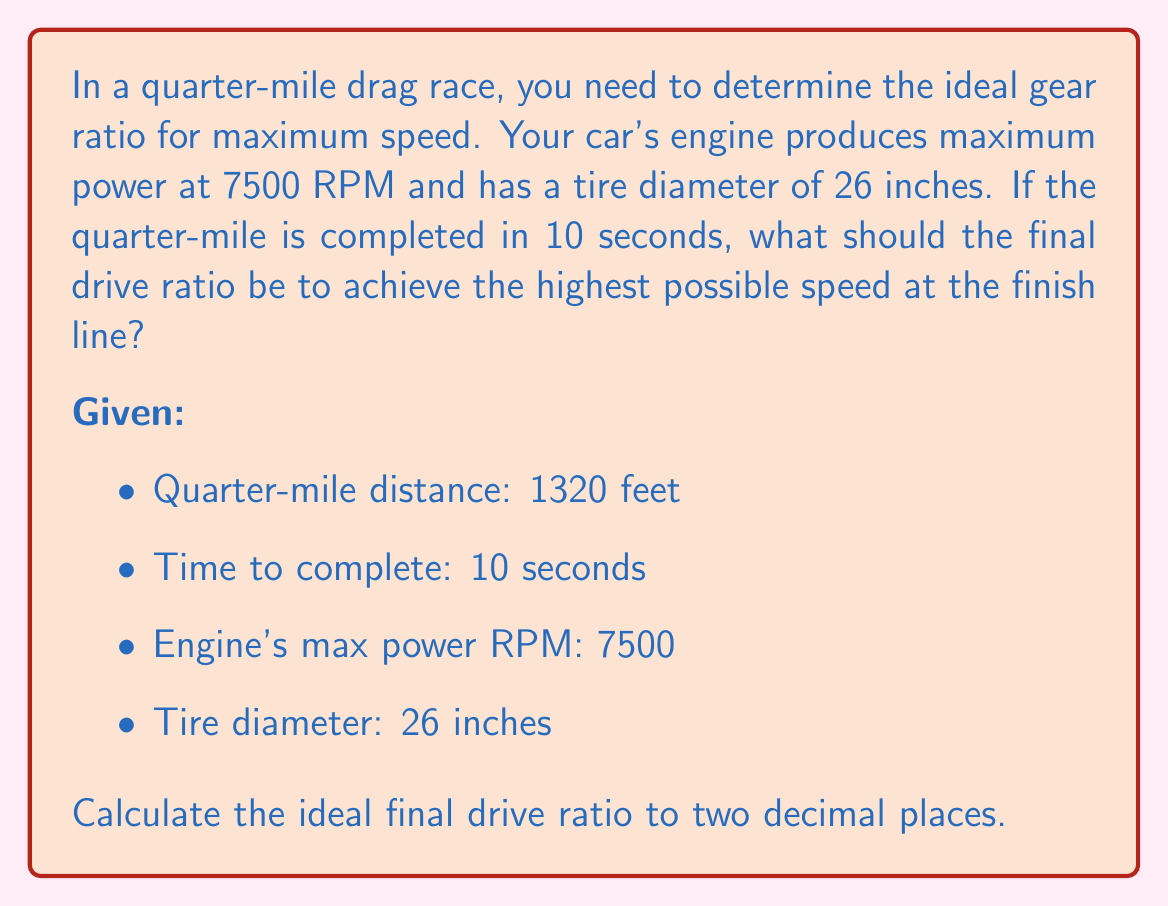Provide a solution to this math problem. Let's approach this step-by-step:

1) First, calculate the average speed for the quarter-mile:
   $$ \text{Average Speed} = \frac{\text{Distance}}{\text{Time}} = \frac{1320 \text{ feet}}{10 \text{ seconds}} = 132 \text{ ft/s} $$

2) Convert this to mph:
   $$ 132 \text{ ft/s} \times \frac{3600 \text{ s}}{1 \text{ hour}} \times \frac{1 \text{ mile}}{5280 \text{ feet}} = 90 \text{ mph} $$

3) Since this is the average speed, the final speed will be higher. Let's estimate it as 1.5 times the average:
   $$ \text{Final Speed} = 90 \text{ mph} \times 1.5 = 135 \text{ mph} $$

4) Now, calculate the wheel RPM at this speed:
   $$ \text{Wheel RPM} = \frac{\text{Speed (in/min)}}{\text{Tire Circumference (in)}} $$
   $$ = \frac{135 \text{ mph} \times 63360 \text{ in/mile}}{60 \text{ min/hour} \times \pi \times 26 \text{ in}} $$
   $$ \approx 1650 \text{ RPM} $$

5) The ideal gear ratio will match the engine's max power RPM to this wheel RPM:
   $$ \text{Final Drive Ratio} = \frac{\text{Engine RPM}}{\text{Wheel RPM}} = \frac{7500}{1650} \approx 4.55 $$

Therefore, the ideal final drive ratio is approximately 4.55:1.
Answer: 4.55:1 